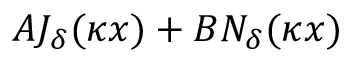Convert formula to latex. <formula><loc_0><loc_0><loc_500><loc_500>A J _ { \delta } ( \kappa x ) + B N _ { \delta } ( \kappa x )</formula> 